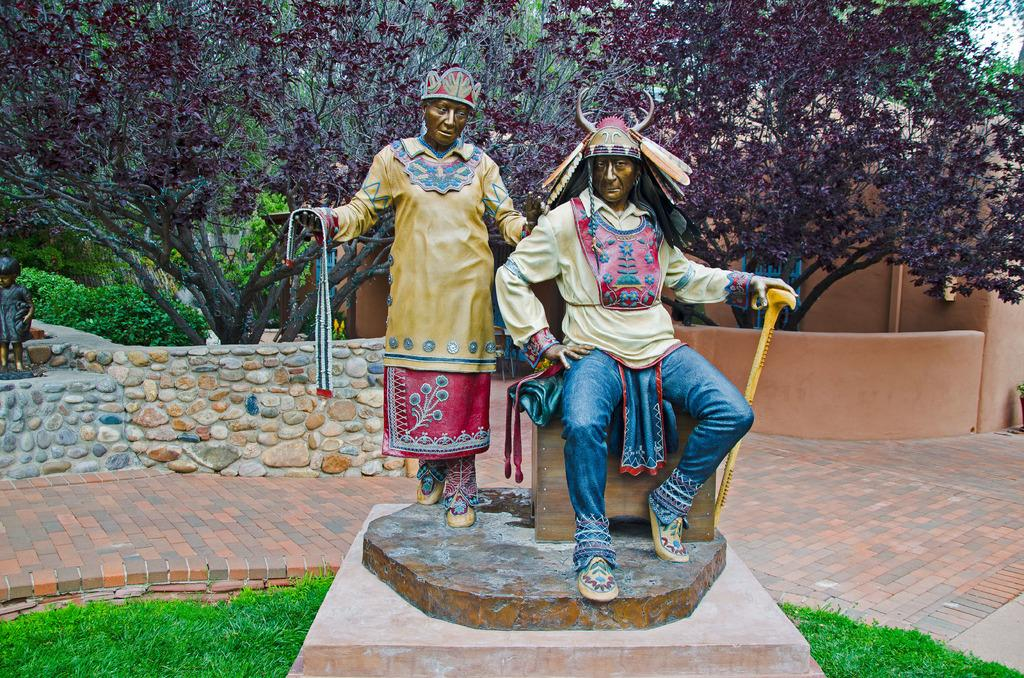What is the main subject in the foreground of the picture? There is a sculpture in the foreground of the picture. What type of ground is visible in the foreground of the picture? There is grass and pavement in the foreground of the picture. What is the wall in the foreground of the picture made of? The wall in the foreground of the picture is not specified, but it could be made of various materials like brick, stone, or concrete. What can be seen in the background of the picture? There are trees, plants, another sculpture, and a building in the background of the picture. What type of approval is the sculpture seeking in the image? The sculpture is not seeking any approval in the image, as it is a static object and not capable of seeking approval. 